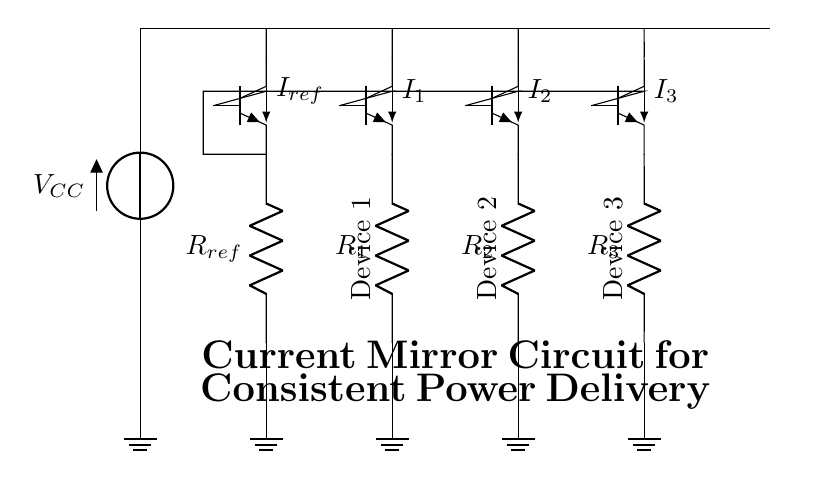What is the reference resistor in the circuit? The reference resistor is labeled as R_ref and is connected to the emitter of Q1, providing a reference current for the current mirror.
Answer: R_ref What is the purpose of the current mirror in this circuit? The current mirror's purpose is to supply consistent current to multiple devices regardless of variations in load conditions, ensuring uniform power delivery to all connected devices.
Answer: Consistent current How many transistors are used in this circuit? There are four transistors labeled Q1, Q2, Q3, and Q4, which form the current mirror arrangement to maintain current consistency.
Answer: Four What is the voltage source connected to the circuit? The voltage source is labeled as V_CC, providing the necessary voltage supply for the circuit operation to power the transistors and loads.
Answer: V_CC What is the output current of the current mirror relative to the reference current? The output current for each device such as I1, I2, and I3 is ideally equal to the reference current I_ref, thus maintaining proportionality for the connected devices.
Answer: I_ref Which components provide connections to ground in the circuit? The circuit has four ground connections, directly connecting the lower ends of R_ref, R_1, R_2, and R_3 to ground, allowing current to flow back to the power supply.
Answer: Four resistors 